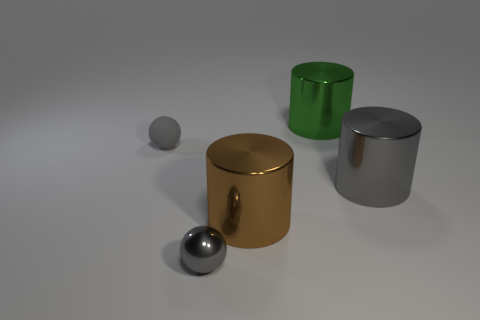What number of spheres are big gray shiny objects or green objects?
Your answer should be very brief. 0. Is the shape of the tiny gray matte thing the same as the gray metallic thing that is to the left of the big brown metal object?
Give a very brief answer. Yes. Is the number of tiny balls on the right side of the big brown cylinder less than the number of large blue objects?
Ensure brevity in your answer.  No. Are there any shiny things in front of the big gray thing?
Provide a succinct answer. Yes. Are there any big gray shiny things of the same shape as the brown shiny object?
Offer a terse response. Yes. There is a object that is the same size as the matte sphere; what shape is it?
Offer a terse response. Sphere. What number of things are either gray things to the left of the tiny gray metallic thing or small things?
Provide a succinct answer. 2. Do the matte ball and the small shiny object have the same color?
Offer a very short reply. Yes. How big is the gray metallic thing to the left of the large green shiny cylinder?
Offer a very short reply. Small. Is there a brown cylinder of the same size as the gray cylinder?
Make the answer very short. Yes. 